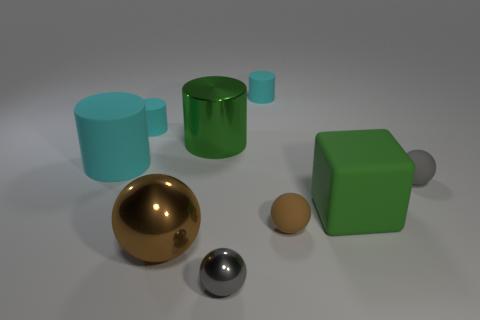Are the large green cube and the large brown ball made of the same material?
Your answer should be compact. No. How many cyan things are the same size as the gray shiny object?
Provide a short and direct response. 2. Is the number of small brown objects that are on the right side of the large block the same as the number of tiny rubber cylinders?
Offer a terse response. No. What number of things are to the right of the big metallic ball and behind the large brown thing?
Provide a succinct answer. 5. Is the shape of the gray object in front of the brown metallic sphere the same as  the large cyan matte thing?
Offer a very short reply. No. What is the material of the green cylinder that is the same size as the matte cube?
Your response must be concise. Metal. Is the number of tiny gray balls that are left of the tiny brown rubber sphere the same as the number of gray spheres that are behind the matte cube?
Make the answer very short. Yes. There is a gray object that is in front of the gray sphere behind the big metal sphere; how many large metallic spheres are in front of it?
Offer a terse response. 0. Do the block and the metallic object in front of the brown metallic ball have the same color?
Offer a very short reply. No. There is a green thing that is made of the same material as the tiny brown object; what size is it?
Make the answer very short. Large. 